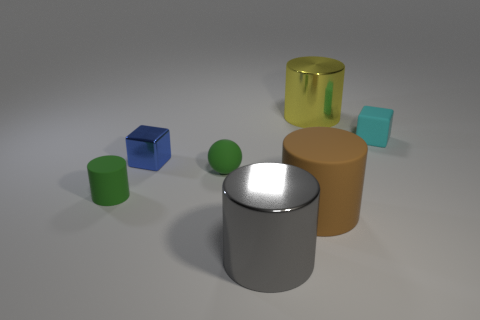There is a tiny rubber cylinder; is it the same color as the small rubber sphere that is to the left of the large brown cylinder?
Your response must be concise. Yes. Is there a green cylinder that has the same material as the gray cylinder?
Your answer should be compact. No. There is a matte object that is the same color as the small rubber sphere; what is its size?
Ensure brevity in your answer.  Small. How many yellow things are small shiny spheres or large objects?
Offer a terse response. 1. Are there any matte objects of the same color as the large rubber cylinder?
Make the answer very short. No. The ball that is made of the same material as the cyan thing is what size?
Make the answer very short. Small. How many balls are big brown things or cyan objects?
Provide a short and direct response. 0. Are there more large purple things than small green cylinders?
Offer a terse response. No. What number of cyan rubber objects are the same size as the green ball?
Offer a terse response. 1. There is a small rubber object that is the same color as the sphere; what is its shape?
Offer a very short reply. Cylinder. 